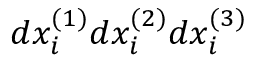Convert formula to latex. <formula><loc_0><loc_0><loc_500><loc_500>d x _ { i } ^ { ( 1 ) } d x _ { i } ^ { ( 2 ) } d x _ { i } ^ { ( 3 ) }</formula> 